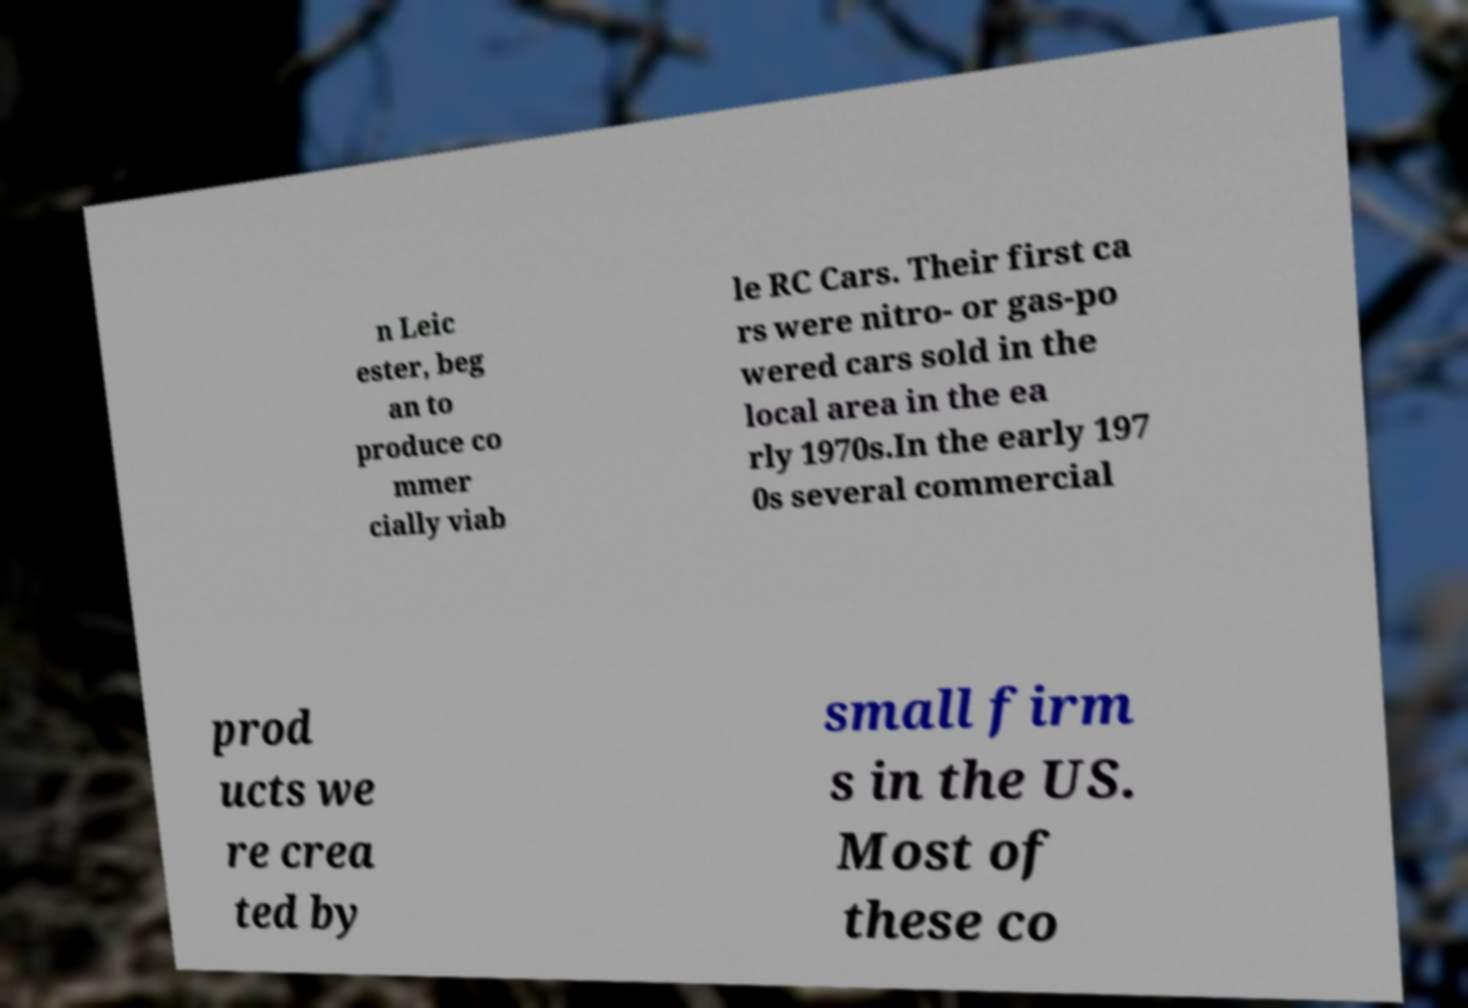Could you assist in decoding the text presented in this image and type it out clearly? n Leic ester, beg an to produce co mmer cially viab le RC Cars. Their first ca rs were nitro- or gas-po wered cars sold in the local area in the ea rly 1970s.In the early 197 0s several commercial prod ucts we re crea ted by small firm s in the US. Most of these co 